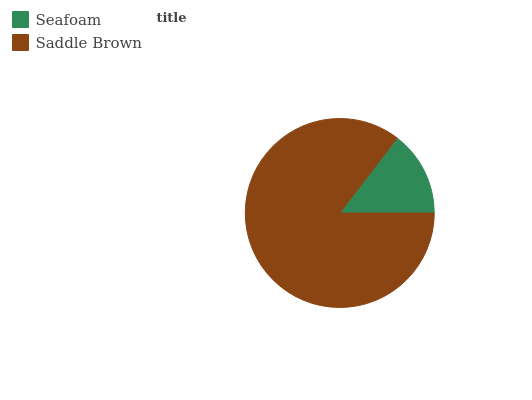Is Seafoam the minimum?
Answer yes or no. Yes. Is Saddle Brown the maximum?
Answer yes or no. Yes. Is Saddle Brown the minimum?
Answer yes or no. No. Is Saddle Brown greater than Seafoam?
Answer yes or no. Yes. Is Seafoam less than Saddle Brown?
Answer yes or no. Yes. Is Seafoam greater than Saddle Brown?
Answer yes or no. No. Is Saddle Brown less than Seafoam?
Answer yes or no. No. Is Saddle Brown the high median?
Answer yes or no. Yes. Is Seafoam the low median?
Answer yes or no. Yes. Is Seafoam the high median?
Answer yes or no. No. Is Saddle Brown the low median?
Answer yes or no. No. 